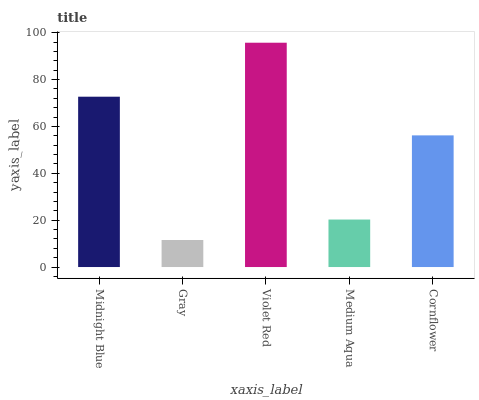Is Violet Red the minimum?
Answer yes or no. No. Is Gray the maximum?
Answer yes or no. No. Is Violet Red greater than Gray?
Answer yes or no. Yes. Is Gray less than Violet Red?
Answer yes or no. Yes. Is Gray greater than Violet Red?
Answer yes or no. No. Is Violet Red less than Gray?
Answer yes or no. No. Is Cornflower the high median?
Answer yes or no. Yes. Is Cornflower the low median?
Answer yes or no. Yes. Is Gray the high median?
Answer yes or no. No. Is Medium Aqua the low median?
Answer yes or no. No. 